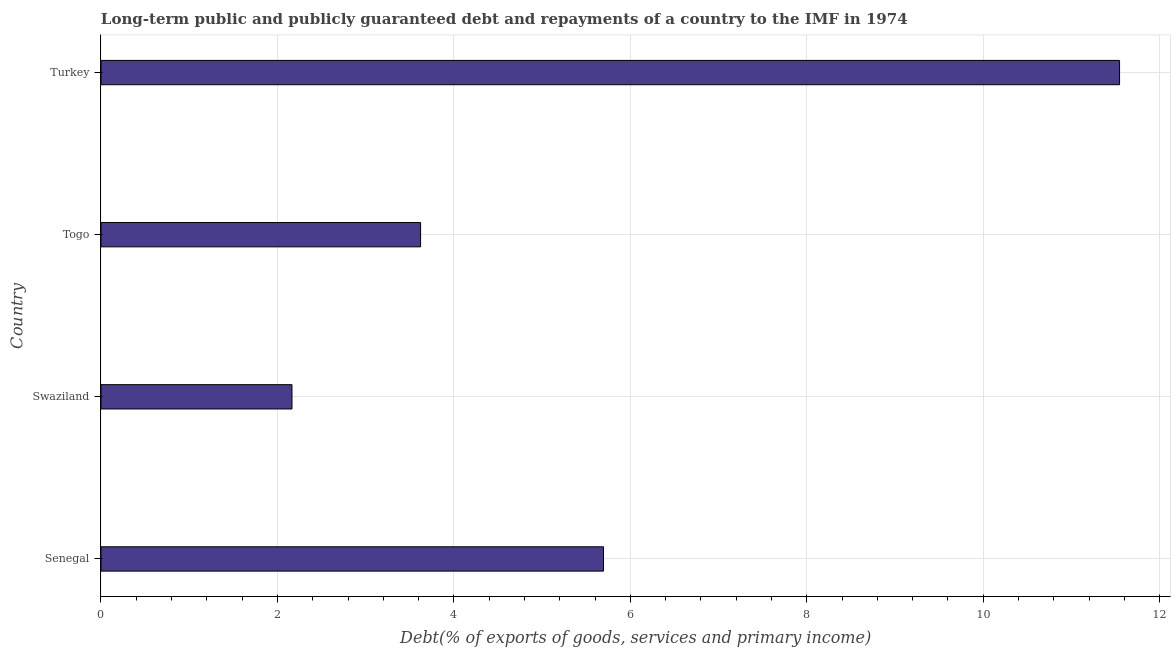What is the title of the graph?
Ensure brevity in your answer.  Long-term public and publicly guaranteed debt and repayments of a country to the IMF in 1974. What is the label or title of the X-axis?
Your response must be concise. Debt(% of exports of goods, services and primary income). What is the label or title of the Y-axis?
Your answer should be very brief. Country. What is the debt service in Senegal?
Your answer should be very brief. 5.7. Across all countries, what is the maximum debt service?
Provide a short and direct response. 11.55. Across all countries, what is the minimum debt service?
Make the answer very short. 2.17. In which country was the debt service minimum?
Offer a terse response. Swaziland. What is the sum of the debt service?
Your answer should be compact. 23.03. What is the difference between the debt service in Swaziland and Togo?
Provide a succinct answer. -1.46. What is the average debt service per country?
Keep it short and to the point. 5.76. What is the median debt service?
Keep it short and to the point. 4.66. What is the ratio of the debt service in Senegal to that in Swaziland?
Make the answer very short. 2.63. What is the difference between the highest and the second highest debt service?
Keep it short and to the point. 5.85. What is the difference between the highest and the lowest debt service?
Give a very brief answer. 9.38. In how many countries, is the debt service greater than the average debt service taken over all countries?
Ensure brevity in your answer.  1. What is the difference between two consecutive major ticks on the X-axis?
Ensure brevity in your answer.  2. Are the values on the major ticks of X-axis written in scientific E-notation?
Provide a short and direct response. No. What is the Debt(% of exports of goods, services and primary income) in Senegal?
Your answer should be very brief. 5.7. What is the Debt(% of exports of goods, services and primary income) in Swaziland?
Keep it short and to the point. 2.17. What is the Debt(% of exports of goods, services and primary income) in Togo?
Offer a very short reply. 3.62. What is the Debt(% of exports of goods, services and primary income) in Turkey?
Provide a succinct answer. 11.55. What is the difference between the Debt(% of exports of goods, services and primary income) in Senegal and Swaziland?
Keep it short and to the point. 3.53. What is the difference between the Debt(% of exports of goods, services and primary income) in Senegal and Togo?
Your response must be concise. 2.07. What is the difference between the Debt(% of exports of goods, services and primary income) in Senegal and Turkey?
Give a very brief answer. -5.85. What is the difference between the Debt(% of exports of goods, services and primary income) in Swaziland and Togo?
Make the answer very short. -1.46. What is the difference between the Debt(% of exports of goods, services and primary income) in Swaziland and Turkey?
Provide a succinct answer. -9.38. What is the difference between the Debt(% of exports of goods, services and primary income) in Togo and Turkey?
Ensure brevity in your answer.  -7.92. What is the ratio of the Debt(% of exports of goods, services and primary income) in Senegal to that in Swaziland?
Offer a very short reply. 2.63. What is the ratio of the Debt(% of exports of goods, services and primary income) in Senegal to that in Togo?
Make the answer very short. 1.57. What is the ratio of the Debt(% of exports of goods, services and primary income) in Senegal to that in Turkey?
Offer a terse response. 0.49. What is the ratio of the Debt(% of exports of goods, services and primary income) in Swaziland to that in Togo?
Offer a very short reply. 0.6. What is the ratio of the Debt(% of exports of goods, services and primary income) in Swaziland to that in Turkey?
Ensure brevity in your answer.  0.19. What is the ratio of the Debt(% of exports of goods, services and primary income) in Togo to that in Turkey?
Your answer should be very brief. 0.31. 